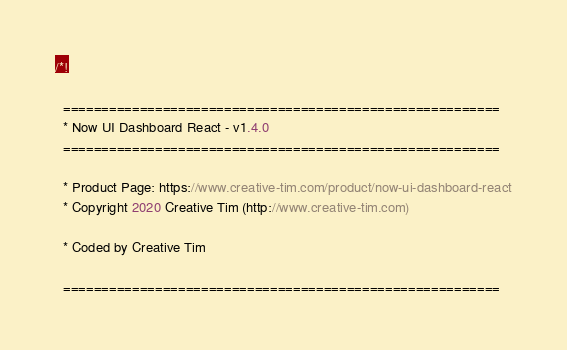<code> <loc_0><loc_0><loc_500><loc_500><_JavaScript_>/*!

  =========================================================
  * Now UI Dashboard React - v1.4.0
  =========================================================

  * Product Page: https://www.creative-tim.com/product/now-ui-dashboard-react
  * Copyright 2020 Creative Tim (http://www.creative-tim.com)

  * Coded by Creative Tim

  =========================================================
</code> 